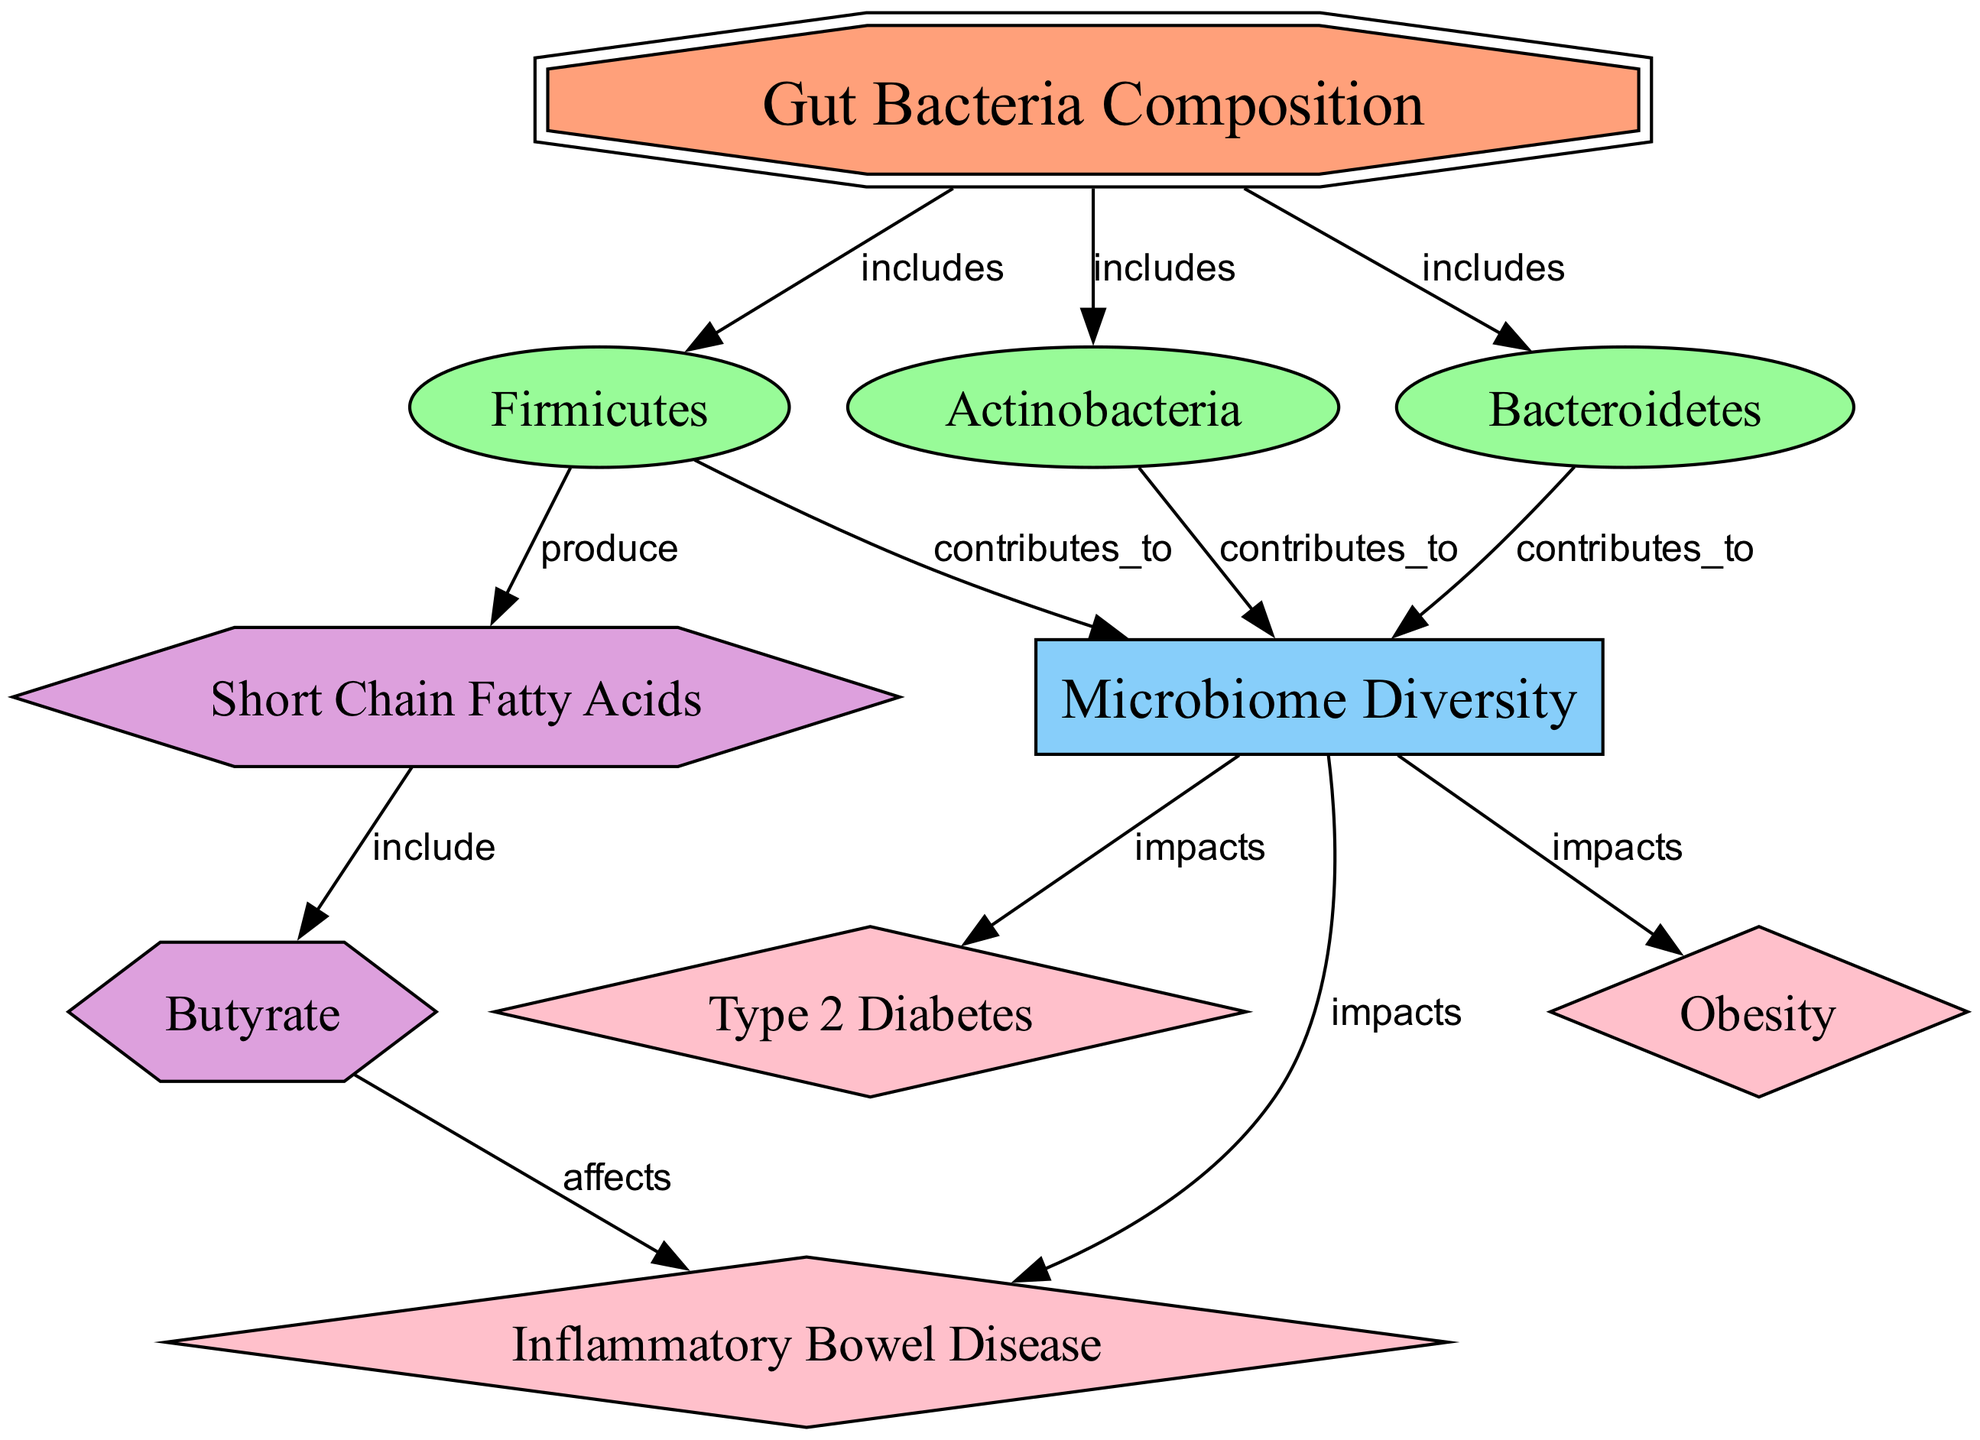What are the three main groups of gut bacteria? The diagram specifies three groups of gut bacteria: Bacteroidetes, Firmicutes, and Actinobacteria, which are all identified as specific types of bacteria under the main topic of Gut Bacteria Composition.
Answer: Bacteroidetes, Firmicutes, Actinobacteria How many diseases are impacted by microbiome diversity? The diagram shows three diseases that are impacted by microbiome diversity: Obesity, Type 2 Diabetes, and Inflammatory Bowel Disease. This indicates a direct influence of the diversity of gut bacteria on these conditions.
Answer: 3 Which bacteria group contributes to microbiome diversity through the production of short chain fatty acids? The diagram indicates that Firmicutes are responsible for producing short-chain fatty acids, which then relates to the overall microbiome diversity as they contribute to various metabolic processes.
Answer: Firmicutes What compound is included in short chain fatty acids according to the diagram? The diagram specifies that butyrate is included in the category of short-chain fatty acids, establishing a clear relationship between the two nodes.
Answer: Butyrate Which disease is most directly affected by butyrate? The diagram indicates that butyrate specifically affects Inflammatory Bowel Disease, illustrating its role in metabolic disease mechanisms.
Answer: Inflammatory Bowel Disease How does microbiome diversity impact metabolic diseases? The diagram shows that microbiome diversity impacts Obesity, Type 2 Diabetes, and Inflammatory Bowel Disease, outlining the relationships and effects between gut bacteria composition and these metabolic diseases.
Answer: Obesity, Type 2 Diabetes, Inflammatory Bowel Disease Which node has connections to multiple bacteria groups? The Gut Bacteria Composition node has connections to three bacteria groups: Bacteroidetes, Firmicutes, and Actinobacteria, demonstrating its central role in the diagram.
Answer: Gut Bacteria Composition What is the relationship between Firmicutes and short-chain fatty acids? The diagram illustrates that Firmicutes produce short-chain fatty acids, indicating a production relationship that highlights their contribution to gut health and metabolic processes.
Answer: produce 